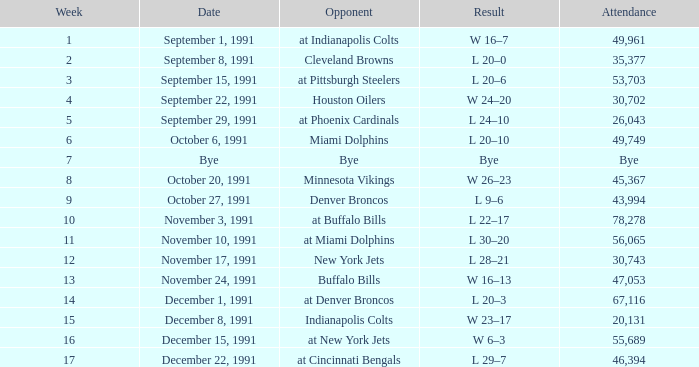What was the result of the game after Week 13 on December 8, 1991? W 23–17. 